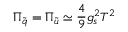Convert formula to latex. <formula><loc_0><loc_0><loc_500><loc_500>\Pi _ { \tilde { q } } = \Pi _ { \tilde { u } } \simeq \frac { 4 } { 9 } g _ { s } ^ { 2 } T ^ { 2 }</formula> 